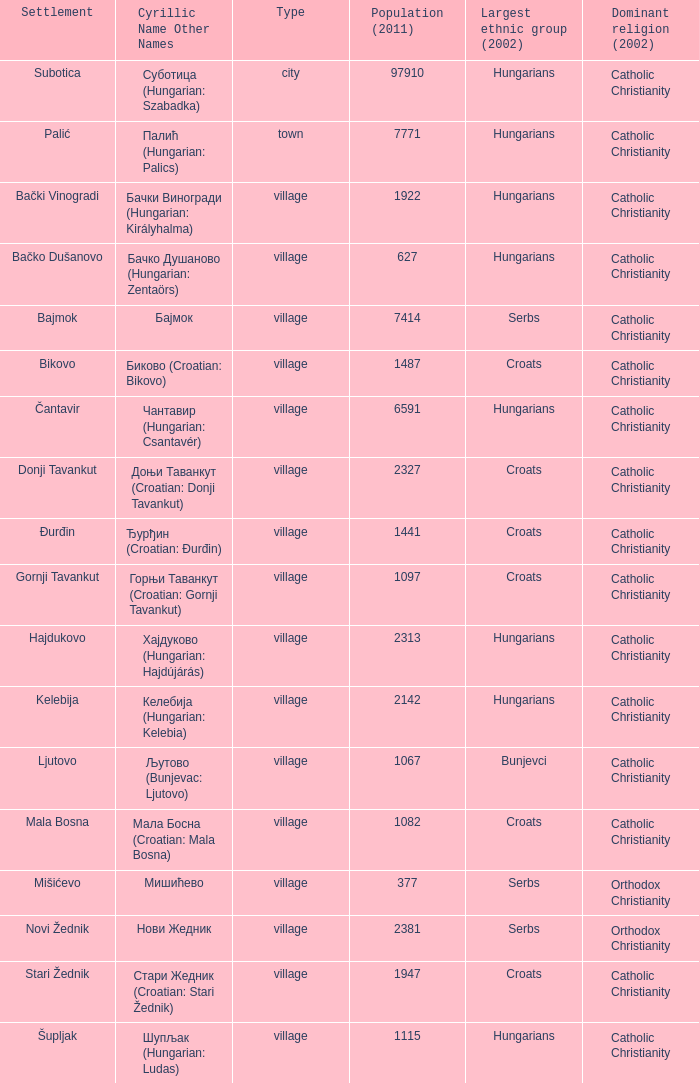Which form of habitation consists of 1441 residents? Village. 